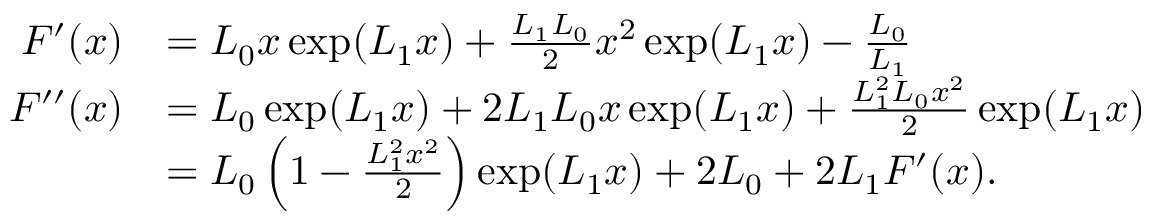Convert formula to latex. <formula><loc_0><loc_0><loc_500><loc_500>\begin{array} { r l } { F ^ { \prime } ( x ) } & { = L _ { 0 } x \exp ( L _ { 1 } x ) + \frac { L _ { 1 } L _ { 0 } } { 2 } x ^ { 2 } \exp ( L _ { 1 } x ) - \frac { L _ { 0 } } { L _ { 1 } } } \\ { F ^ { \prime \prime } ( x ) } & { = L _ { 0 } \exp ( L _ { 1 } x ) + 2 L _ { 1 } L _ { 0 } x \exp ( L _ { 1 } x ) + \frac { L _ { 1 } ^ { 2 } L _ { 0 } x ^ { 2 } } { 2 } \exp ( L _ { 1 } x ) } \\ & { = L _ { 0 } \left ( 1 - \frac { L _ { 1 } ^ { 2 } x ^ { 2 } } { 2 } \right ) \exp ( L _ { 1 } x ) + 2 L _ { 0 } + 2 L _ { 1 } F ^ { \prime } ( x ) . } \end{array}</formula> 